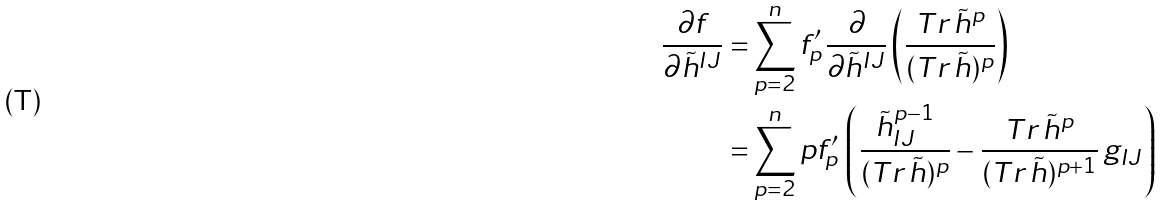Convert formula to latex. <formula><loc_0><loc_0><loc_500><loc_500>\frac { \partial f } { \partial \tilde { h } ^ { I J } } = & \sum _ { p = 2 } ^ { n } f ^ { \prime } _ { p } \, \frac { \partial } { \partial \tilde { h } ^ { I J } } \left ( \frac { T r \, \tilde { h } ^ { p } } { ( T r \, \tilde { h } ) ^ { p } } \right ) \\ = & \sum _ { p = 2 } ^ { n } p f ^ { \prime } _ { p } \, \left ( \frac { \tilde { h } ^ { p - 1 } _ { I J } } { ( T r \, \tilde { h } ) ^ { p } } - \frac { T r \, \tilde { h } ^ { p } } { ( T r \, \tilde { h } ) ^ { p + 1 } } \, g _ { I J } \right )</formula> 